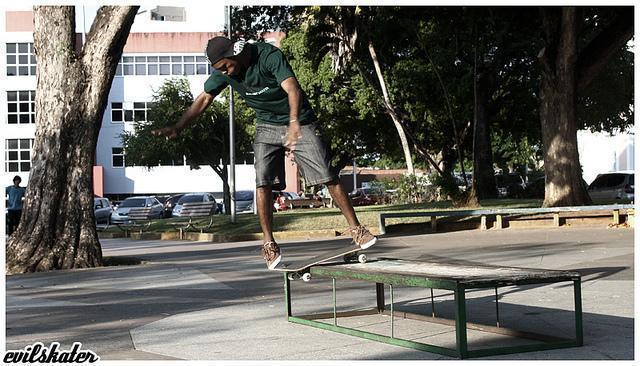What wheeled object is the man riding on to perform the stunt?
From the following set of four choices, select the accurate answer to respond to the question.
Options: Motorcycle, skateboard, rollerblades, bike. Skateboard. 